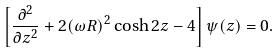<formula> <loc_0><loc_0><loc_500><loc_500>\left [ { \frac { \partial ^ { 2 } } { \partial z ^ { 2 } } } + 2 ( \omega R ) ^ { 2 } \cosh 2 z - 4 \right ] \psi ( z ) = 0 .</formula> 